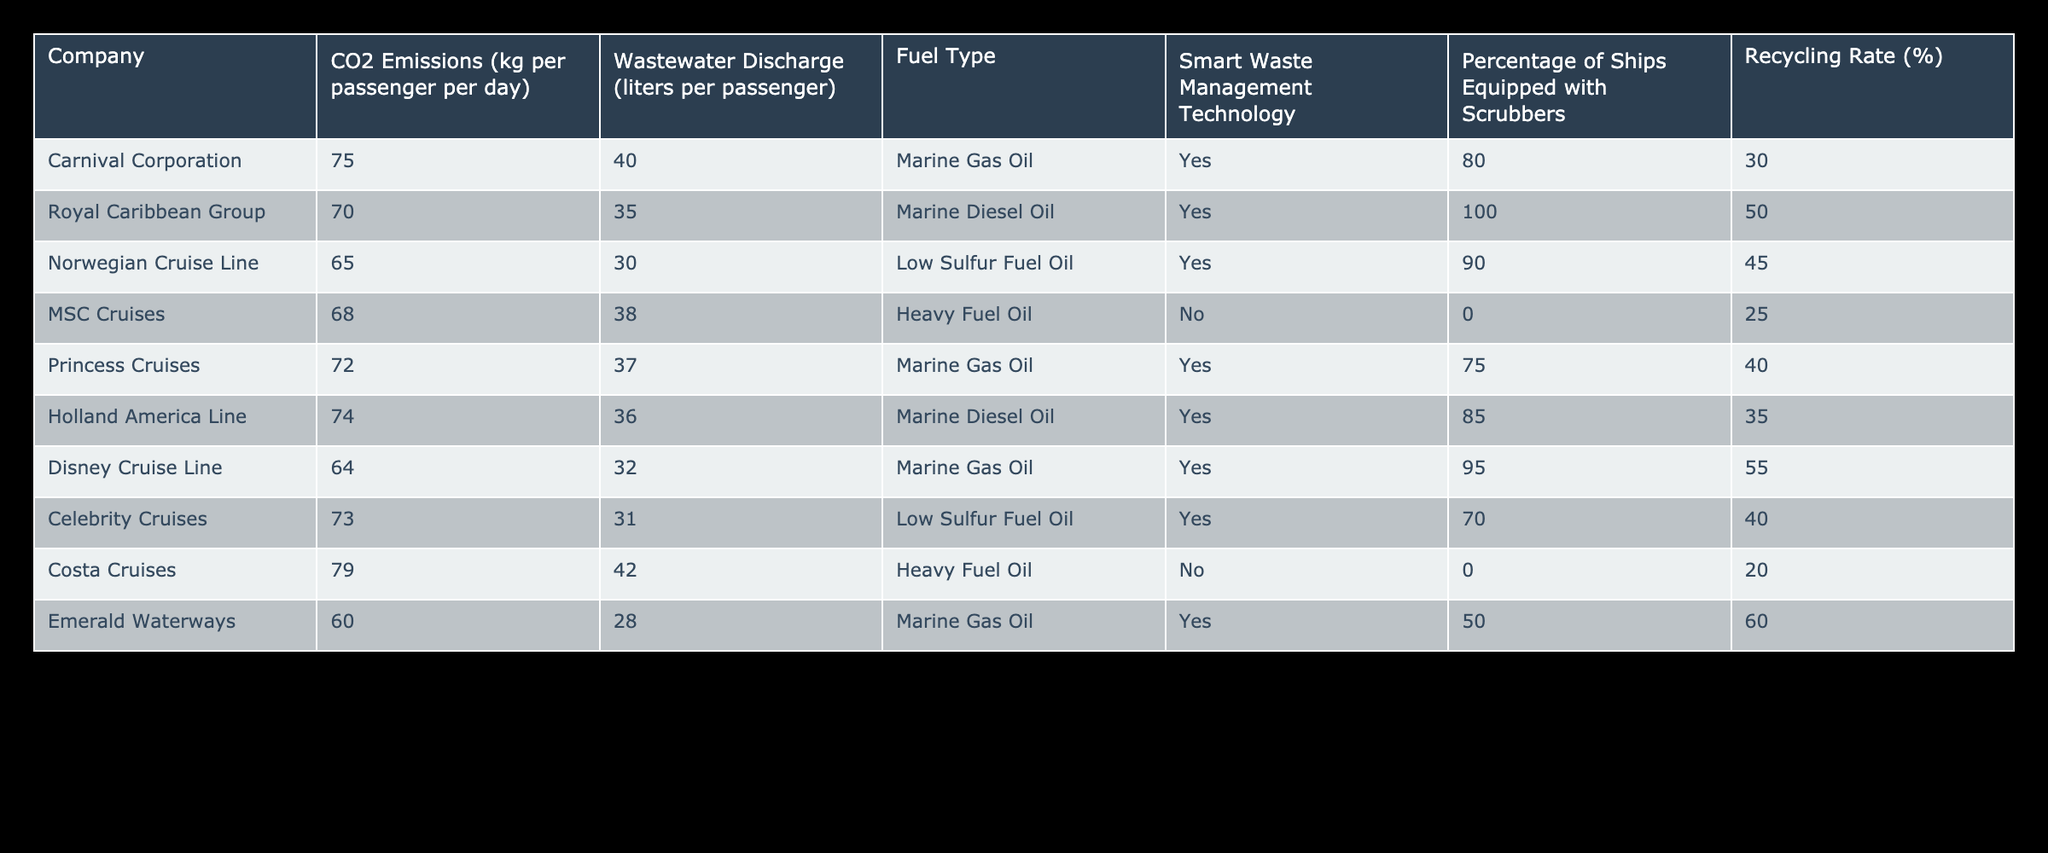What are the CO2 emissions per passenger per day for Disney Cruise Line? Referring to the table, Disney Cruise Line has CO2 emissions listed as 64 kg per passenger per day.
Answer: 64 kg Which company has the highest recycling rate? By examining the recycling rates of each company in the table, Emerald Waterways has the highest recycling rate at 60%.
Answer: 60% Does MSC Cruises utilize smart waste management technology? The table indicates that MSC Cruises does not have smart waste management technology equipped, marked as "No."
Answer: No What is the average wastewater discharge per passenger across all companies? To find the average, sum the wastewater discharges: (40 + 35 + 30 + 38 + 37 + 36 + 32 + 31 + 42 + 28) =  388 liters. Dividing by the number of companies (10), the average is 388/10 = 38.8 liters.
Answer: 38.8 liters How many companies have a recycling rate higher than 40%? Evaluating the recycling rates for companies, the ones exceeding 40% are Royal Caribbean Group (50%), Norwegian Cruise Line (45%), Disney Cruise Line (55%), and Emerald Waterways (60%). This results in a total of four companies.
Answer: 4 What is the difference in CO2 emissions between the company with the lowest and the company with the highest emissions? The lowest CO2 emissions are from Emerald Waterways at 60 kg, whereas the highest emissions are from Costa Cruises at 79 kg. The difference is calculated as 79 - 60 = 19 kg.
Answer: 19 kg Which fuel type is used by the Norwegian Cruise Line? The table lists the fuel type used by Norwegian Cruise Line as Low Sulfur Fuel Oil.
Answer: Low Sulfur Fuel Oil What percentage of ships equipped with scrubbers does the Royal Caribbean Group have? According to the table, the Royal Caribbean Group has 100% of its ships equipped with scrubbers.
Answer: 100% 